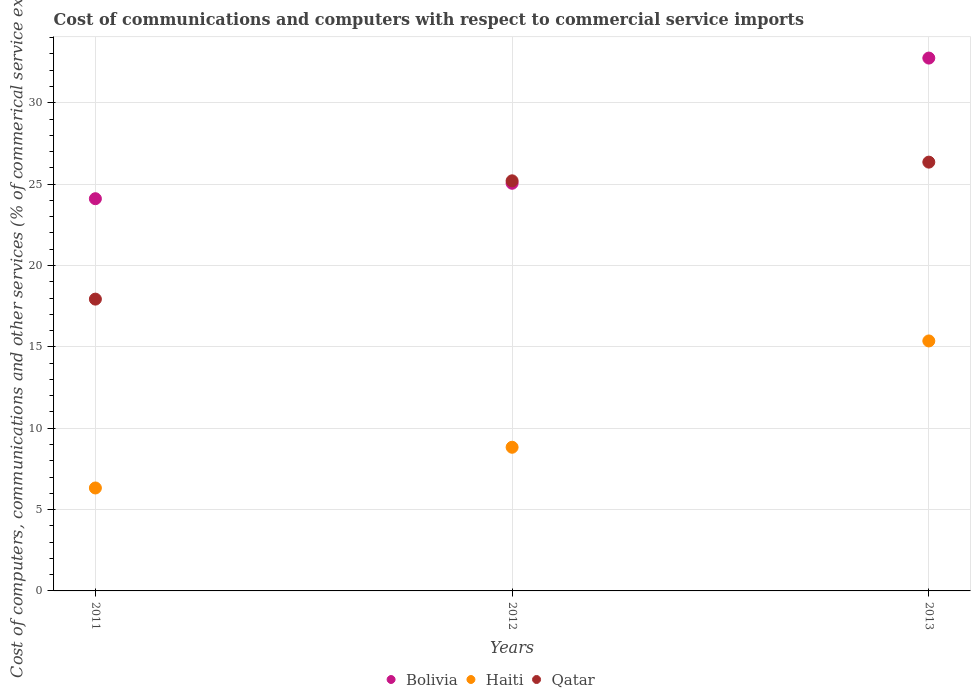How many different coloured dotlines are there?
Your response must be concise. 3. Is the number of dotlines equal to the number of legend labels?
Provide a short and direct response. Yes. What is the cost of communications and computers in Haiti in 2013?
Provide a succinct answer. 15.36. Across all years, what is the maximum cost of communications and computers in Bolivia?
Keep it short and to the point. 32.75. Across all years, what is the minimum cost of communications and computers in Haiti?
Provide a succinct answer. 6.33. What is the total cost of communications and computers in Qatar in the graph?
Offer a very short reply. 69.49. What is the difference between the cost of communications and computers in Haiti in 2011 and that in 2013?
Your answer should be compact. -9.04. What is the difference between the cost of communications and computers in Haiti in 2011 and the cost of communications and computers in Qatar in 2013?
Give a very brief answer. -20.02. What is the average cost of communications and computers in Haiti per year?
Provide a short and direct response. 10.17. In the year 2011, what is the difference between the cost of communications and computers in Bolivia and cost of communications and computers in Haiti?
Your response must be concise. 17.78. In how many years, is the cost of communications and computers in Haiti greater than 18 %?
Ensure brevity in your answer.  0. What is the ratio of the cost of communications and computers in Bolivia in 2011 to that in 2013?
Offer a terse response. 0.74. Is the cost of communications and computers in Bolivia in 2011 less than that in 2013?
Offer a terse response. Yes. What is the difference between the highest and the second highest cost of communications and computers in Qatar?
Keep it short and to the point. 1.15. What is the difference between the highest and the lowest cost of communications and computers in Bolivia?
Ensure brevity in your answer.  8.64. In how many years, is the cost of communications and computers in Haiti greater than the average cost of communications and computers in Haiti taken over all years?
Your answer should be compact. 1. Is the cost of communications and computers in Bolivia strictly greater than the cost of communications and computers in Qatar over the years?
Your answer should be compact. No. Does the graph contain any zero values?
Provide a short and direct response. No. Does the graph contain grids?
Provide a short and direct response. Yes. How many legend labels are there?
Your answer should be compact. 3. How are the legend labels stacked?
Give a very brief answer. Horizontal. What is the title of the graph?
Your response must be concise. Cost of communications and computers with respect to commercial service imports. What is the label or title of the Y-axis?
Give a very brief answer. Cost of computers, communications and other services (% of commerical service exports). What is the Cost of computers, communications and other services (% of commerical service exports) of Bolivia in 2011?
Keep it short and to the point. 24.1. What is the Cost of computers, communications and other services (% of commerical service exports) of Haiti in 2011?
Ensure brevity in your answer.  6.33. What is the Cost of computers, communications and other services (% of commerical service exports) of Qatar in 2011?
Your answer should be very brief. 17.93. What is the Cost of computers, communications and other services (% of commerical service exports) in Bolivia in 2012?
Your response must be concise. 25.05. What is the Cost of computers, communications and other services (% of commerical service exports) of Haiti in 2012?
Give a very brief answer. 8.83. What is the Cost of computers, communications and other services (% of commerical service exports) of Qatar in 2012?
Your answer should be compact. 25.2. What is the Cost of computers, communications and other services (% of commerical service exports) of Bolivia in 2013?
Your response must be concise. 32.75. What is the Cost of computers, communications and other services (% of commerical service exports) of Haiti in 2013?
Your response must be concise. 15.36. What is the Cost of computers, communications and other services (% of commerical service exports) in Qatar in 2013?
Your answer should be compact. 26.35. Across all years, what is the maximum Cost of computers, communications and other services (% of commerical service exports) of Bolivia?
Offer a very short reply. 32.75. Across all years, what is the maximum Cost of computers, communications and other services (% of commerical service exports) of Haiti?
Your response must be concise. 15.36. Across all years, what is the maximum Cost of computers, communications and other services (% of commerical service exports) in Qatar?
Your answer should be very brief. 26.35. Across all years, what is the minimum Cost of computers, communications and other services (% of commerical service exports) of Bolivia?
Offer a terse response. 24.1. Across all years, what is the minimum Cost of computers, communications and other services (% of commerical service exports) in Haiti?
Make the answer very short. 6.33. Across all years, what is the minimum Cost of computers, communications and other services (% of commerical service exports) in Qatar?
Your answer should be compact. 17.93. What is the total Cost of computers, communications and other services (% of commerical service exports) of Bolivia in the graph?
Offer a terse response. 81.9. What is the total Cost of computers, communications and other services (% of commerical service exports) of Haiti in the graph?
Your answer should be very brief. 30.52. What is the total Cost of computers, communications and other services (% of commerical service exports) in Qatar in the graph?
Offer a terse response. 69.49. What is the difference between the Cost of computers, communications and other services (% of commerical service exports) in Bolivia in 2011 and that in 2012?
Your response must be concise. -0.95. What is the difference between the Cost of computers, communications and other services (% of commerical service exports) of Haiti in 2011 and that in 2012?
Offer a terse response. -2.5. What is the difference between the Cost of computers, communications and other services (% of commerical service exports) in Qatar in 2011 and that in 2012?
Offer a very short reply. -7.27. What is the difference between the Cost of computers, communications and other services (% of commerical service exports) of Bolivia in 2011 and that in 2013?
Your response must be concise. -8.64. What is the difference between the Cost of computers, communications and other services (% of commerical service exports) in Haiti in 2011 and that in 2013?
Make the answer very short. -9.04. What is the difference between the Cost of computers, communications and other services (% of commerical service exports) of Qatar in 2011 and that in 2013?
Offer a terse response. -8.42. What is the difference between the Cost of computers, communications and other services (% of commerical service exports) of Bolivia in 2012 and that in 2013?
Make the answer very short. -7.69. What is the difference between the Cost of computers, communications and other services (% of commerical service exports) of Haiti in 2012 and that in 2013?
Your response must be concise. -6.53. What is the difference between the Cost of computers, communications and other services (% of commerical service exports) in Qatar in 2012 and that in 2013?
Provide a short and direct response. -1.15. What is the difference between the Cost of computers, communications and other services (% of commerical service exports) in Bolivia in 2011 and the Cost of computers, communications and other services (% of commerical service exports) in Haiti in 2012?
Make the answer very short. 15.27. What is the difference between the Cost of computers, communications and other services (% of commerical service exports) in Bolivia in 2011 and the Cost of computers, communications and other services (% of commerical service exports) in Qatar in 2012?
Your answer should be compact. -1.1. What is the difference between the Cost of computers, communications and other services (% of commerical service exports) in Haiti in 2011 and the Cost of computers, communications and other services (% of commerical service exports) in Qatar in 2012?
Ensure brevity in your answer.  -18.88. What is the difference between the Cost of computers, communications and other services (% of commerical service exports) of Bolivia in 2011 and the Cost of computers, communications and other services (% of commerical service exports) of Haiti in 2013?
Your response must be concise. 8.74. What is the difference between the Cost of computers, communications and other services (% of commerical service exports) in Bolivia in 2011 and the Cost of computers, communications and other services (% of commerical service exports) in Qatar in 2013?
Give a very brief answer. -2.25. What is the difference between the Cost of computers, communications and other services (% of commerical service exports) of Haiti in 2011 and the Cost of computers, communications and other services (% of commerical service exports) of Qatar in 2013?
Provide a succinct answer. -20.02. What is the difference between the Cost of computers, communications and other services (% of commerical service exports) of Bolivia in 2012 and the Cost of computers, communications and other services (% of commerical service exports) of Haiti in 2013?
Your answer should be very brief. 9.69. What is the difference between the Cost of computers, communications and other services (% of commerical service exports) of Bolivia in 2012 and the Cost of computers, communications and other services (% of commerical service exports) of Qatar in 2013?
Keep it short and to the point. -1.3. What is the difference between the Cost of computers, communications and other services (% of commerical service exports) of Haiti in 2012 and the Cost of computers, communications and other services (% of commerical service exports) of Qatar in 2013?
Keep it short and to the point. -17.52. What is the average Cost of computers, communications and other services (% of commerical service exports) in Bolivia per year?
Your response must be concise. 27.3. What is the average Cost of computers, communications and other services (% of commerical service exports) in Haiti per year?
Keep it short and to the point. 10.17. What is the average Cost of computers, communications and other services (% of commerical service exports) of Qatar per year?
Keep it short and to the point. 23.16. In the year 2011, what is the difference between the Cost of computers, communications and other services (% of commerical service exports) in Bolivia and Cost of computers, communications and other services (% of commerical service exports) in Haiti?
Make the answer very short. 17.78. In the year 2011, what is the difference between the Cost of computers, communications and other services (% of commerical service exports) of Bolivia and Cost of computers, communications and other services (% of commerical service exports) of Qatar?
Ensure brevity in your answer.  6.17. In the year 2011, what is the difference between the Cost of computers, communications and other services (% of commerical service exports) of Haiti and Cost of computers, communications and other services (% of commerical service exports) of Qatar?
Give a very brief answer. -11.61. In the year 2012, what is the difference between the Cost of computers, communications and other services (% of commerical service exports) of Bolivia and Cost of computers, communications and other services (% of commerical service exports) of Haiti?
Give a very brief answer. 16.22. In the year 2012, what is the difference between the Cost of computers, communications and other services (% of commerical service exports) in Bolivia and Cost of computers, communications and other services (% of commerical service exports) in Qatar?
Provide a short and direct response. -0.15. In the year 2012, what is the difference between the Cost of computers, communications and other services (% of commerical service exports) in Haiti and Cost of computers, communications and other services (% of commerical service exports) in Qatar?
Make the answer very short. -16.37. In the year 2013, what is the difference between the Cost of computers, communications and other services (% of commerical service exports) in Bolivia and Cost of computers, communications and other services (% of commerical service exports) in Haiti?
Offer a very short reply. 17.38. In the year 2013, what is the difference between the Cost of computers, communications and other services (% of commerical service exports) of Bolivia and Cost of computers, communications and other services (% of commerical service exports) of Qatar?
Ensure brevity in your answer.  6.39. In the year 2013, what is the difference between the Cost of computers, communications and other services (% of commerical service exports) in Haiti and Cost of computers, communications and other services (% of commerical service exports) in Qatar?
Ensure brevity in your answer.  -10.99. What is the ratio of the Cost of computers, communications and other services (% of commerical service exports) of Bolivia in 2011 to that in 2012?
Ensure brevity in your answer.  0.96. What is the ratio of the Cost of computers, communications and other services (% of commerical service exports) in Haiti in 2011 to that in 2012?
Offer a terse response. 0.72. What is the ratio of the Cost of computers, communications and other services (% of commerical service exports) in Qatar in 2011 to that in 2012?
Ensure brevity in your answer.  0.71. What is the ratio of the Cost of computers, communications and other services (% of commerical service exports) of Bolivia in 2011 to that in 2013?
Offer a terse response. 0.74. What is the ratio of the Cost of computers, communications and other services (% of commerical service exports) of Haiti in 2011 to that in 2013?
Offer a terse response. 0.41. What is the ratio of the Cost of computers, communications and other services (% of commerical service exports) in Qatar in 2011 to that in 2013?
Ensure brevity in your answer.  0.68. What is the ratio of the Cost of computers, communications and other services (% of commerical service exports) of Bolivia in 2012 to that in 2013?
Provide a succinct answer. 0.77. What is the ratio of the Cost of computers, communications and other services (% of commerical service exports) in Haiti in 2012 to that in 2013?
Provide a succinct answer. 0.57. What is the ratio of the Cost of computers, communications and other services (% of commerical service exports) in Qatar in 2012 to that in 2013?
Provide a succinct answer. 0.96. What is the difference between the highest and the second highest Cost of computers, communications and other services (% of commerical service exports) in Bolivia?
Your answer should be very brief. 7.69. What is the difference between the highest and the second highest Cost of computers, communications and other services (% of commerical service exports) in Haiti?
Your answer should be compact. 6.53. What is the difference between the highest and the second highest Cost of computers, communications and other services (% of commerical service exports) of Qatar?
Your answer should be compact. 1.15. What is the difference between the highest and the lowest Cost of computers, communications and other services (% of commerical service exports) in Bolivia?
Provide a short and direct response. 8.64. What is the difference between the highest and the lowest Cost of computers, communications and other services (% of commerical service exports) in Haiti?
Your answer should be very brief. 9.04. What is the difference between the highest and the lowest Cost of computers, communications and other services (% of commerical service exports) of Qatar?
Offer a terse response. 8.42. 